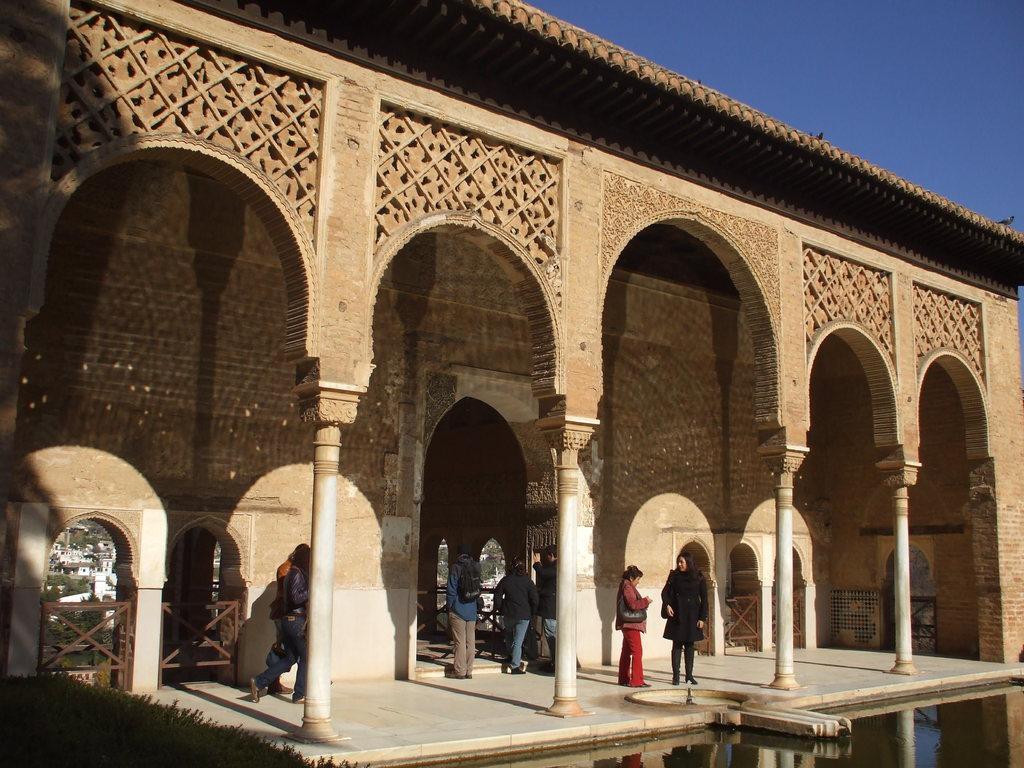Please provide a concise description of this image. In this image I can see a building and windows which is in brown and white color. I can see few people,pillars and water. The sky is in blue color. 